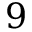Convert formula to latex. <formula><loc_0><loc_0><loc_500><loc_500>9</formula> 